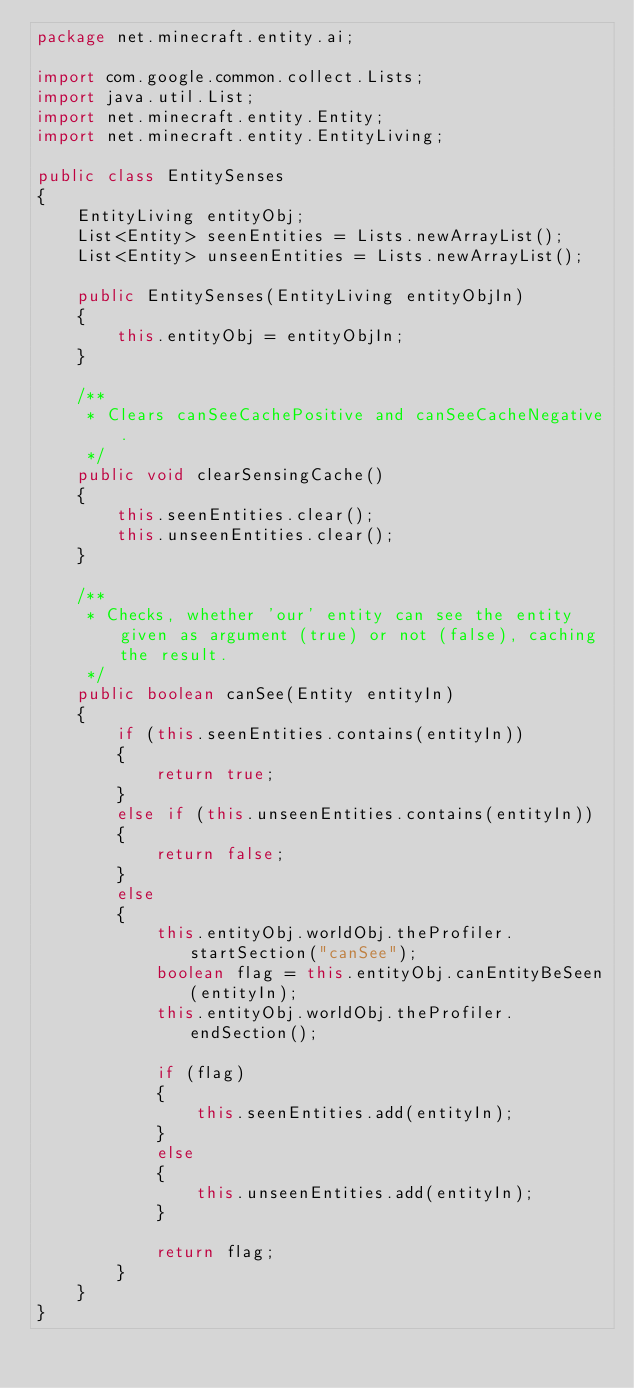<code> <loc_0><loc_0><loc_500><loc_500><_Java_>package net.minecraft.entity.ai;

import com.google.common.collect.Lists;
import java.util.List;
import net.minecraft.entity.Entity;
import net.minecraft.entity.EntityLiving;

public class EntitySenses
{
    EntityLiving entityObj;
    List<Entity> seenEntities = Lists.newArrayList();
    List<Entity> unseenEntities = Lists.newArrayList();

    public EntitySenses(EntityLiving entityObjIn)
    {
        this.entityObj = entityObjIn;
    }

    /**
     * Clears canSeeCachePositive and canSeeCacheNegative.
     */
    public void clearSensingCache()
    {
        this.seenEntities.clear();
        this.unseenEntities.clear();
    }

    /**
     * Checks, whether 'our' entity can see the entity given as argument (true) or not (false), caching the result.
     */
    public boolean canSee(Entity entityIn)
    {
        if (this.seenEntities.contains(entityIn))
        {
            return true;
        }
        else if (this.unseenEntities.contains(entityIn))
        {
            return false;
        }
        else
        {
            this.entityObj.worldObj.theProfiler.startSection("canSee");
            boolean flag = this.entityObj.canEntityBeSeen(entityIn);
            this.entityObj.worldObj.theProfiler.endSection();

            if (flag)
            {
                this.seenEntities.add(entityIn);
            }
            else
            {
                this.unseenEntities.add(entityIn);
            }

            return flag;
        }
    }
}
</code> 